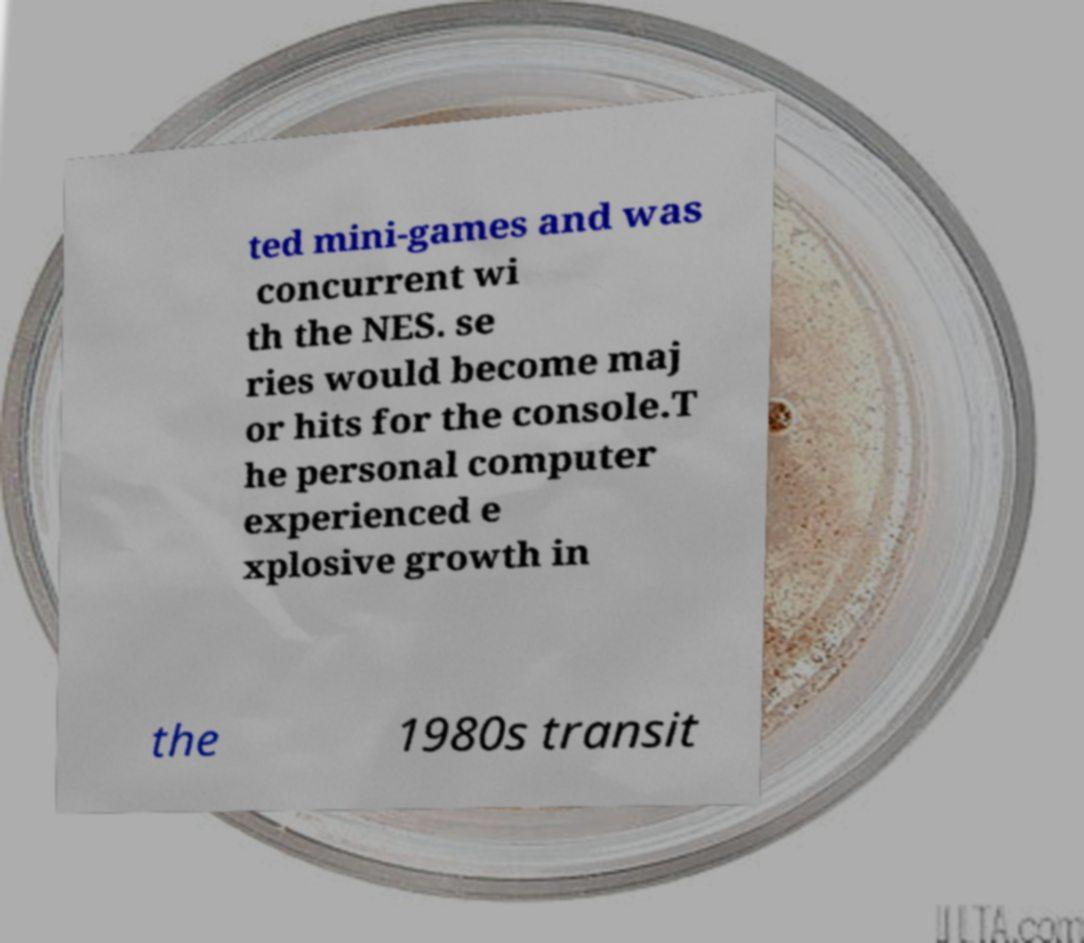Please identify and transcribe the text found in this image. ted mini-games and was concurrent wi th the NES. se ries would become maj or hits for the console.T he personal computer experienced e xplosive growth in the 1980s transit 